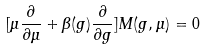Convert formula to latex. <formula><loc_0><loc_0><loc_500><loc_500>[ \mu \frac { \partial } { \partial \mu } + \beta ( g ) \frac { \partial } { \partial g } ] M ( g , \mu ) = 0</formula> 